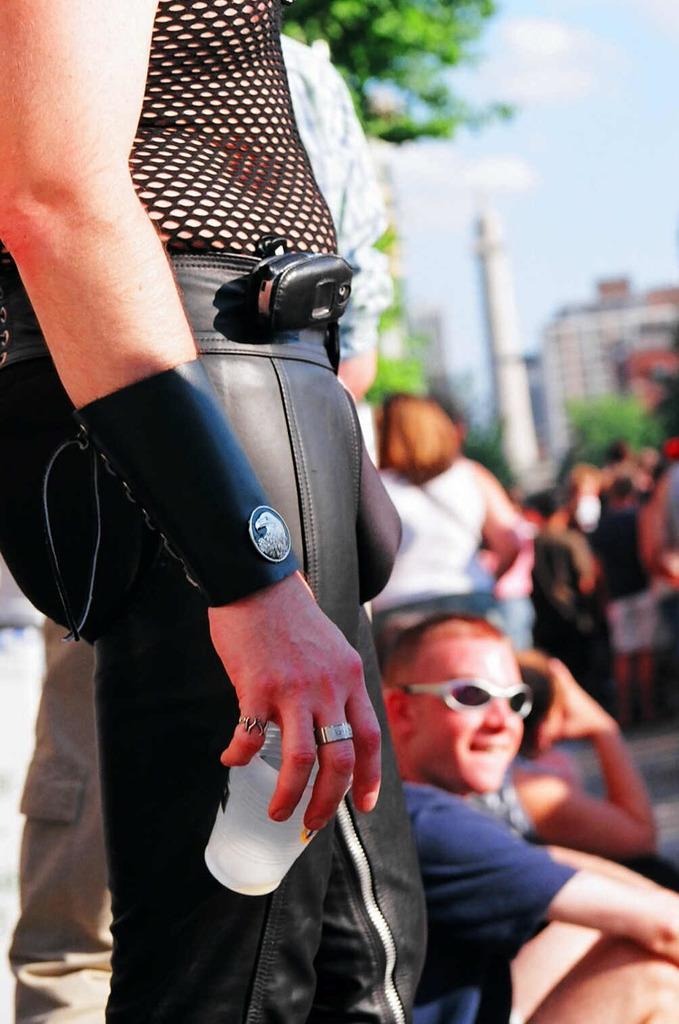Please provide a concise description of this image. In this image I can see people where few are sitting and rest all are standing. Here I can see one person is holding a glass and in background I can see few buildings, few trees and I can see this image is little bit blurry from background. 